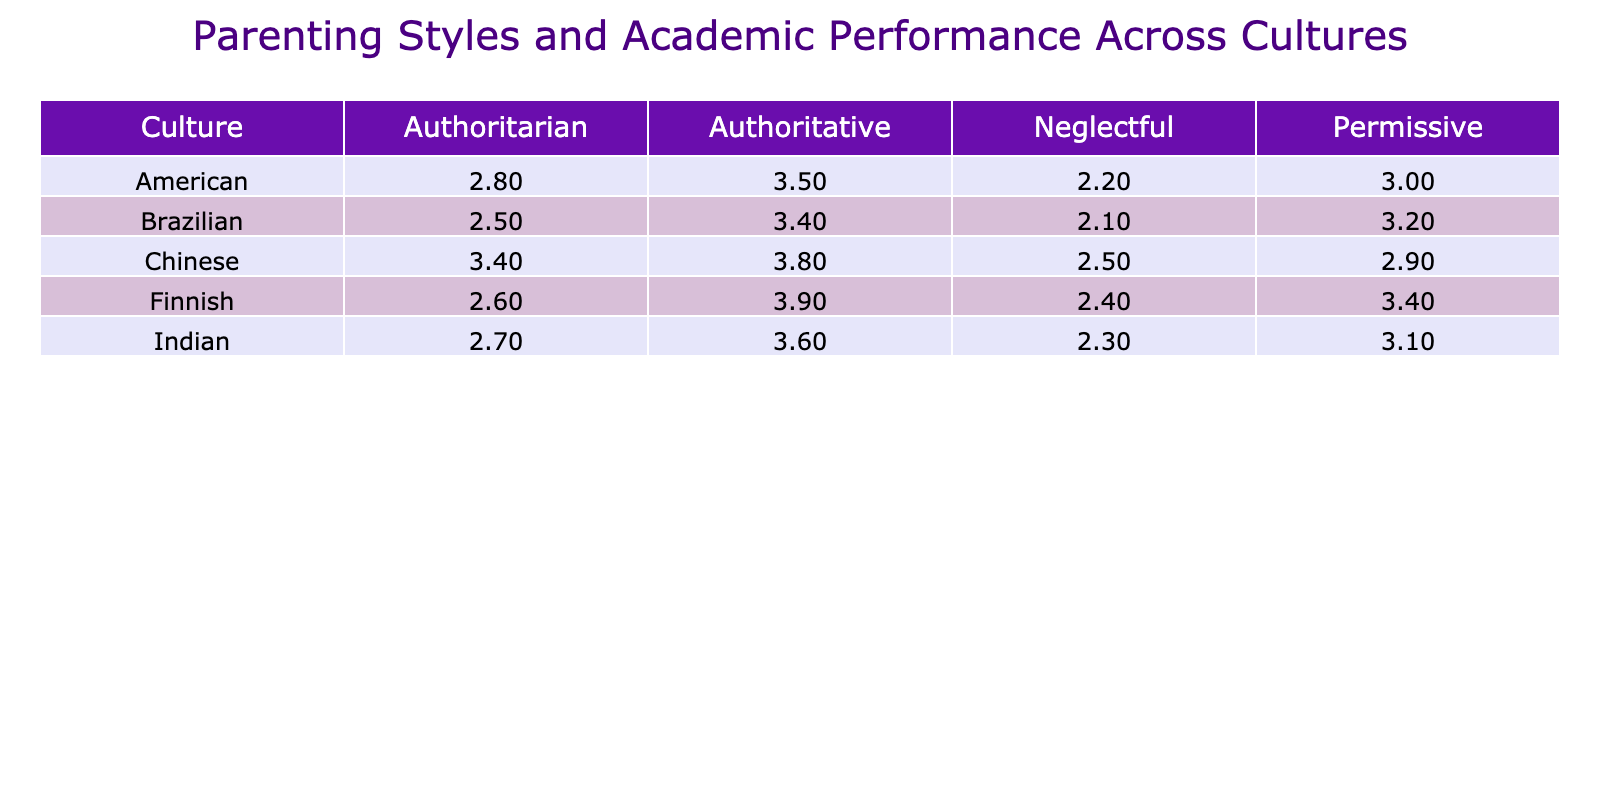What is the average GPA for students with authoritative parenting style across all cultures? To find the average GPA for authoritative parenting style, we first identify the GPAs for each culture with this style: 3.5 (American), 3.8 (Chinese), 3.6 (Indian), 3.9 (Finnish), and 3.4 (Brazilian). We then sum them up: 3.5 + 3.8 + 3.6 + 3.9 + 3.4 = 16.2. Since there are 5 data points, we divide by 5, which yields 16.2 / 5 = 3.24.
Answer: 3.24 Which culture has the lowest average GPA when parenting style is neglectful? Looking at the neglectful parenting style column, the GPAs are: 2.2 (American), 2.5 (Chinese), 2.3 (Indian), 2.4 (Finnish), and 2.1 (Brazilian). The lowest GPA is 2.1 from the Brazilian culture.
Answer: Brazilian Is the average GPA higher for authoritative parenting style than for authoritarian parenting style across all cultures? We need to calculate the average GPA for both styles. The authoritative GPAs are: 3.5, 3.8, 3.6, 3.9, 3.4, summing to 16.2 and taking the average gives 3.24. For the authoritarian GPAs: 2.8, 3.4, 2.7, 2.6, 2.5, summing to 14.0 gives an average of 2.8. Since 3.24 is greater than 2.8, the average GPA for authoritative is higher.
Answer: Yes What is the difference in average GPA between permissive and authoritarian parenting styles? First, we find the average GPA for permissive style: 3.0 (American), 2.9 (Chinese), 3.1 (Indian), 3.4 (Finnish), and 3.2 (Brazilian), which sums to 15.6 and averages to 3.12. For authoritarian, as calculated before, the average is 2.8. The difference is 3.12 - 2.8 = 0.32.
Answer: 0.32 Does any culture have a higher average GPA with neglectful parenting style than any culture with an authoritative parenting style? Checking the neglectful GPAs: 2.2 (American), 2.5 (Chinese), 2.3 (Indian), 2.4 (Finnish), 2.1 (Brazilian), the highest is 2.5. The authoritative GPAs were already found to be 3.5, 3.8, 3.6, 3.9, 3.4. The highest authoritative GPA (3.9) is still greater than the highest neglectful GPA (2.5).
Answer: No Which parenting style has the highest average GPA overall, and what is that GPA? To determine the highest average GPA, we will calculate the average for each parenting style: Authoritative: 3.24, Authoritarian: 2.8, Permissive: 3.12, Neglectful: 2.5. Among these averages, authoritative (3.24) is the highest.
Answer: Authoritative, 3.24 